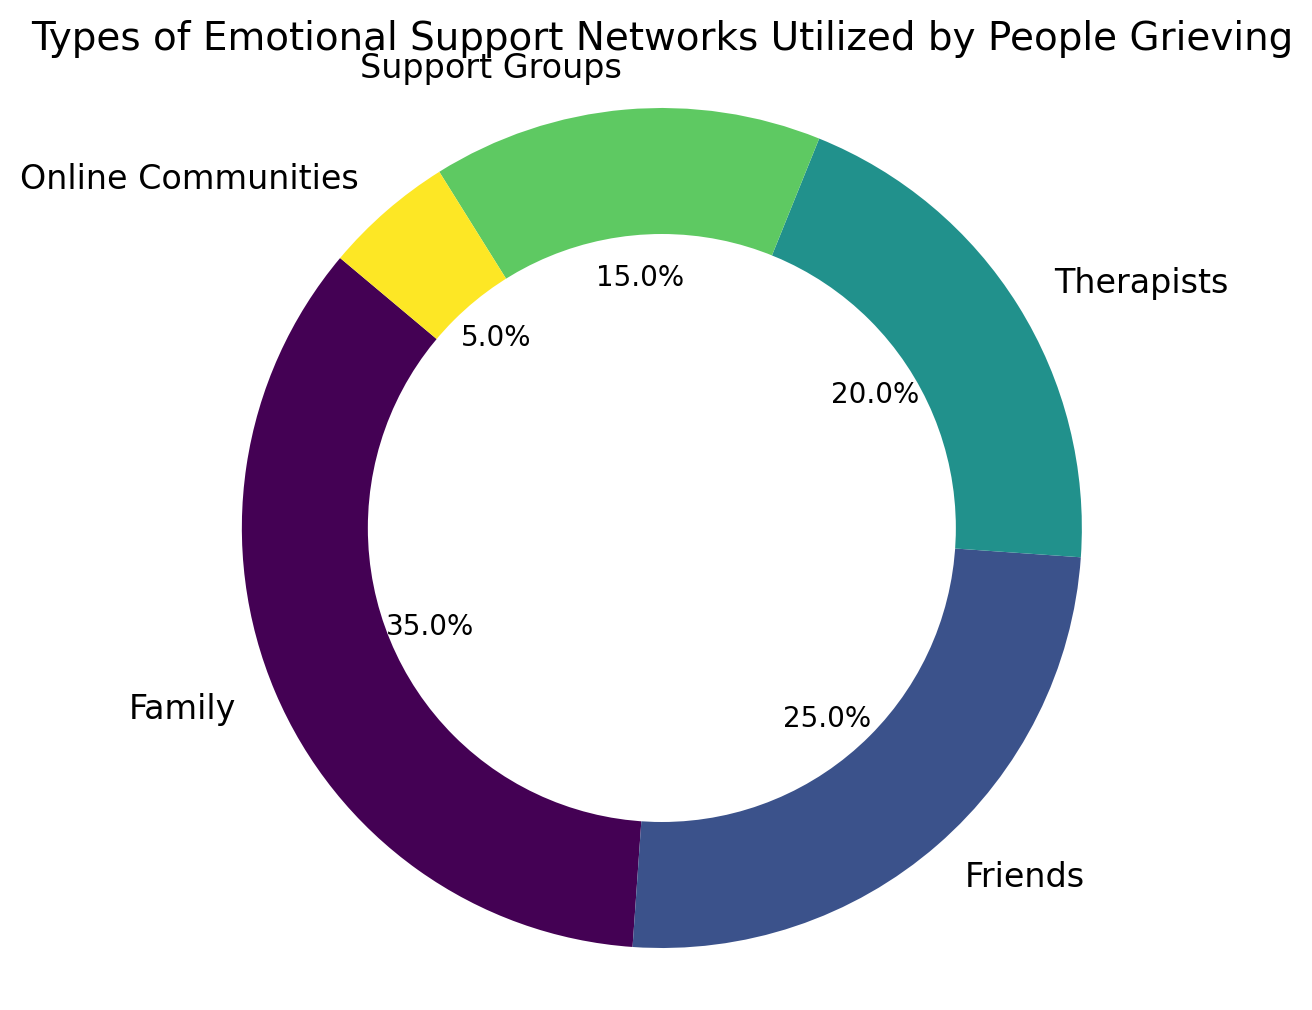what percentage of people rely on Family for emotional support? According to the pie chart, the section labeled "Family" represents 35% of the pie, indicating that 35% of people rely on their family for emotional support.
Answer: 35% which support network is utilized by the smallest percentage of people? The pie chart shows that "Online Communities" has the smallest section, labeled at 5%, indicating it is the least utilized network.
Answer: Online Communities how much more frequently is support from Family utilized compared to Support Groups? From the chart, Family is utilized by 35% and Support Groups by 15%. The difference can be calculated as 35% - 15% = 20%.
Answer: 20% what is the combined percentage of people relying on Friends and Therapists for support? The pie segments for Friends and Therapists are 25% and 20% respectively. Adding these together gives 25% + 20% = 45%.
Answer: 45% is the percentage of people seeking support from Therapists greater than those using Support Groups? Comparing the segments for Therapists (20%) and Support Groups (15%), Therapists have a higher percentage.
Answer: Yes which are the top two most utilized support networks? The pie chart shows that Family (35%) and Friends (25%) occupy the largest segments, making them the top two most utilized networks.
Answer: Family and Friends what percentage of people rely on formal support networks (Therapists and Support Groups) compared to informal networks (Family and Friends)? Adding percentages for Therapists (20%) and Support Groups (15%) gives 35% for formal support. For informal, Family (35%) and Friends (25%) sum to 60%.
Answer: Formal: 35%, Informal: 60% compare the total percentages of people seeking support from online communities with those seeking from therapists. According to the pie chart, Online Communities account for 5% and Therapists for 20%. Comparison shows that Therapists are used by 15% more people.
Answer: Therapists are used 15% more what fraction of the pie represents Support Groups? The chart shows that Support Groups account for 15%. Converting this percentage to a fraction, we get 15/100, which simplifies to 3/20.
Answer: 3/20 